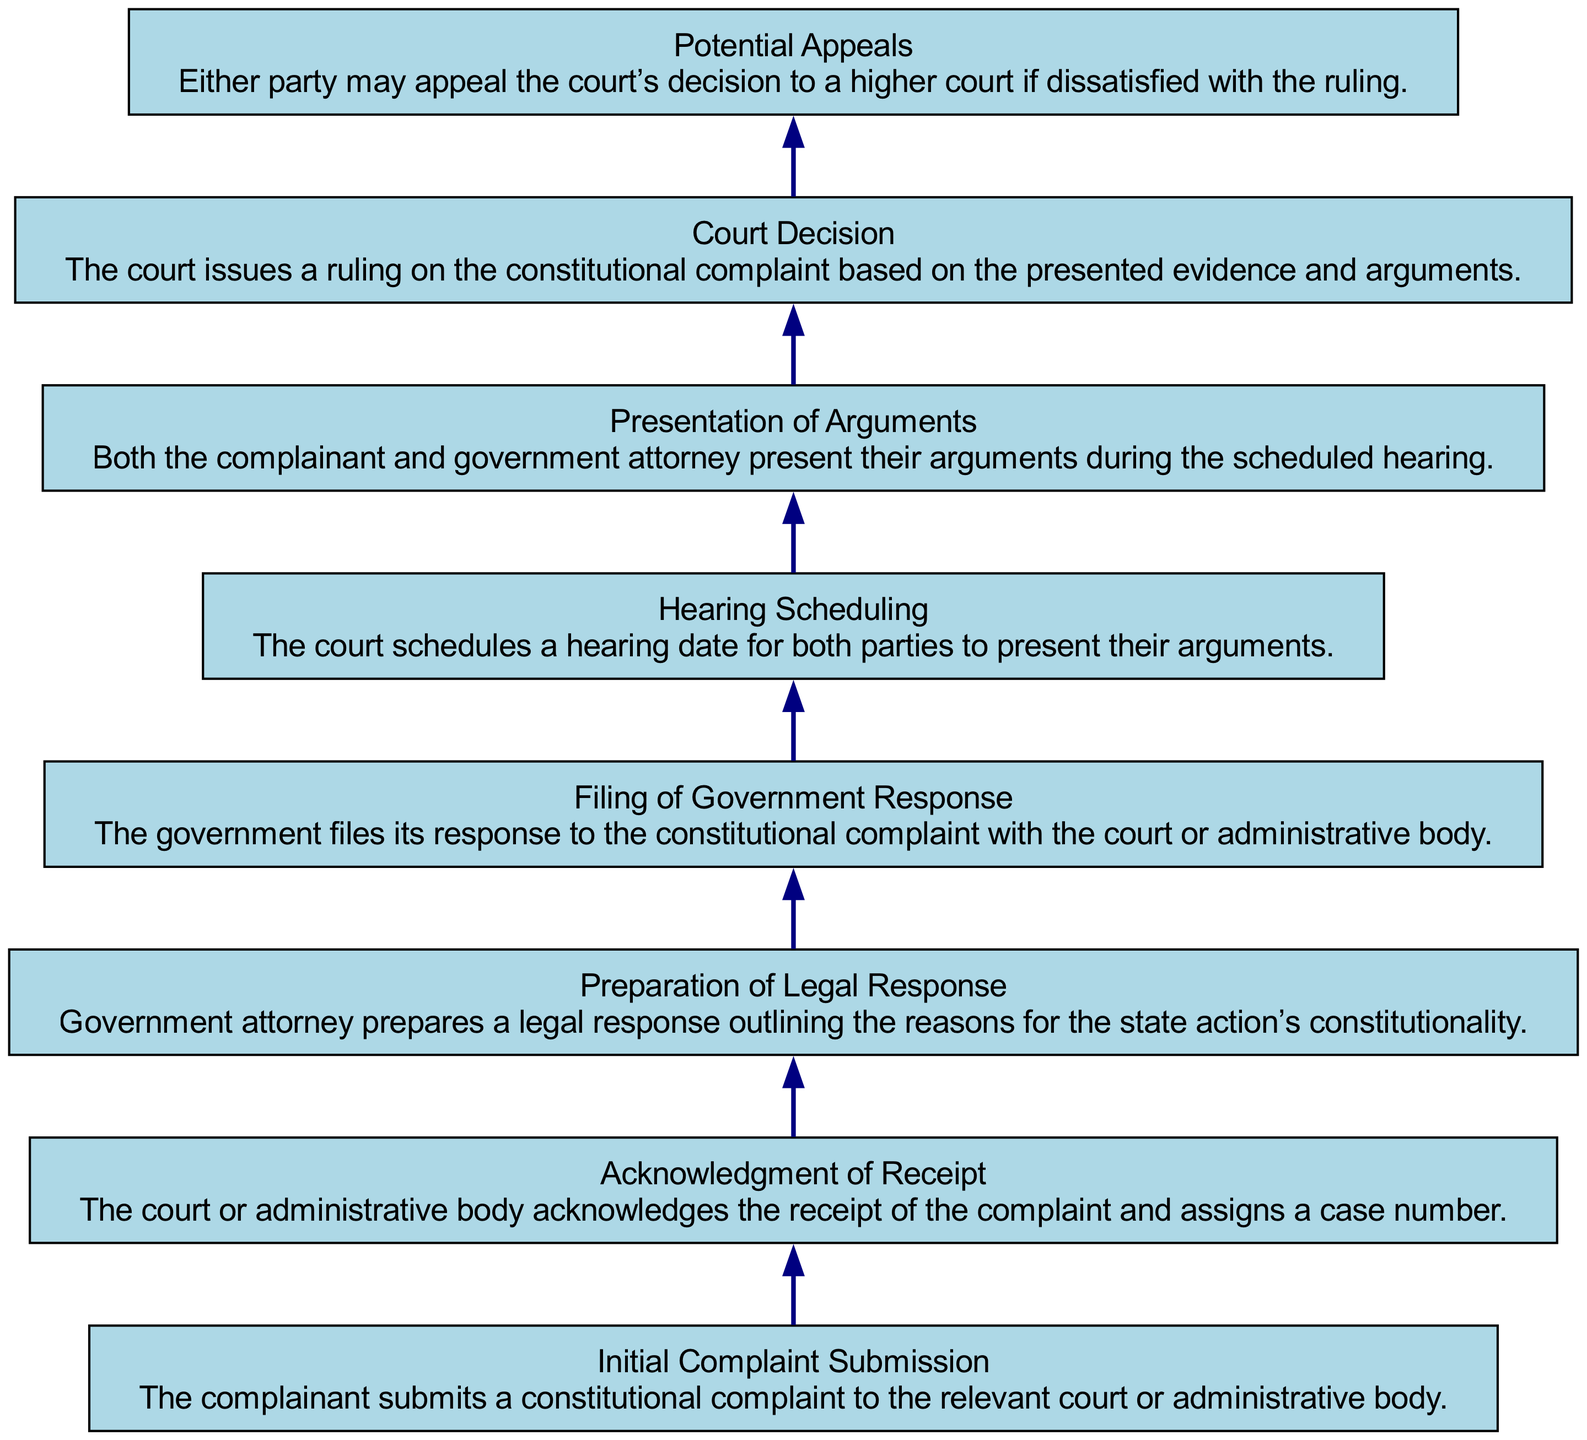What is the first step in the procedure? The first step in the procedure is represented by the node "Initial Complaint Submission," which describes the act of the complainant submitting a constitutional complaint to the relevant court or administrative body.
Answer: Initial Complaint Submission How many nodes are there in the diagram? Counting all the elements in the diagram, there are a total of 8 nodes representing different steps in the procedure.
Answer: 8 What happens after the court acknowledges receipt of the complaint? Following the "Acknowledgment of Receipt," the next step is "Preparation of Legal Response," where the government attorney prepares a legal response detailing the constitutionality of the state action.
Answer: Preparation of Legal Response Which step involves presenting arguments? The step that involves presenting arguments is "Presentation of Arguments," where both the complainant and government attorney present their cases during the scheduled hearing.
Answer: Presentation of Arguments What is the final action in the procedure? The final action in the procedure, as indicated by the last node, is "Court Decision," where the court issues a ruling based on the evidence and arguments presented.
Answer: Court Decision What is the relationship between "Filing of Government Response" and "Hearing Scheduling"? The relationship shows that after the "Filing of Government Response," the next step is "Hearing Scheduling," indicating that once the government responds, the court will schedule a hearing date.
Answer: Hearing Scheduling If a party is dissatisfied with the court ruling, what can they do? If a party is dissatisfied with the court’s ruling, they may engage in "Potential Appeals," wherein they can appeal the decision to a higher court.
Answer: Potential Appeals Describe the purpose of the "Preparation of Legal Response" step. The "Preparation of Legal Response" step serves as the stage where the government attorney outlines the reasons supporting the constitutionality of state action in response to the complaint submitted.
Answer: Outlining constitutionality reasons 